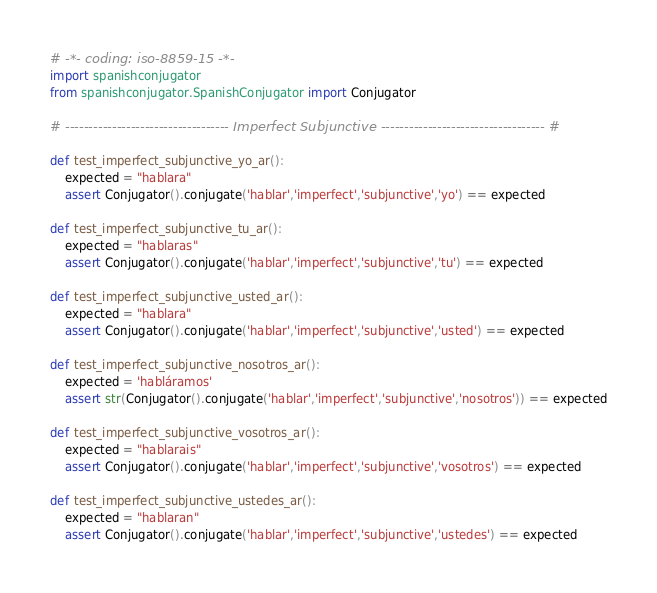Convert code to text. <code><loc_0><loc_0><loc_500><loc_500><_Python_># -*- coding: iso-8859-15 -*-
import spanishconjugator
from spanishconjugator.SpanishConjugator import Conjugator

# ----------------------------------- Imperfect Subjunctive ----------------------------------- #

def test_imperfect_subjunctive_yo_ar():
    expected = "hablara"
    assert Conjugator().conjugate('hablar','imperfect','subjunctive','yo') == expected

def test_imperfect_subjunctive_tu_ar():
    expected = "hablaras"
    assert Conjugator().conjugate('hablar','imperfect','subjunctive','tu') == expected

def test_imperfect_subjunctive_usted_ar():
    expected = "hablara"
    assert Conjugator().conjugate('hablar','imperfect','subjunctive','usted') == expected

def test_imperfect_subjunctive_nosotros_ar():
    expected = 'habláramos'
    assert str(Conjugator().conjugate('hablar','imperfect','subjunctive','nosotros')) == expected

def test_imperfect_subjunctive_vosotros_ar():
    expected = "hablarais"
    assert Conjugator().conjugate('hablar','imperfect','subjunctive','vosotros') == expected

def test_imperfect_subjunctive_ustedes_ar():
    expected = "hablaran"
    assert Conjugator().conjugate('hablar','imperfect','subjunctive','ustedes') == expected</code> 